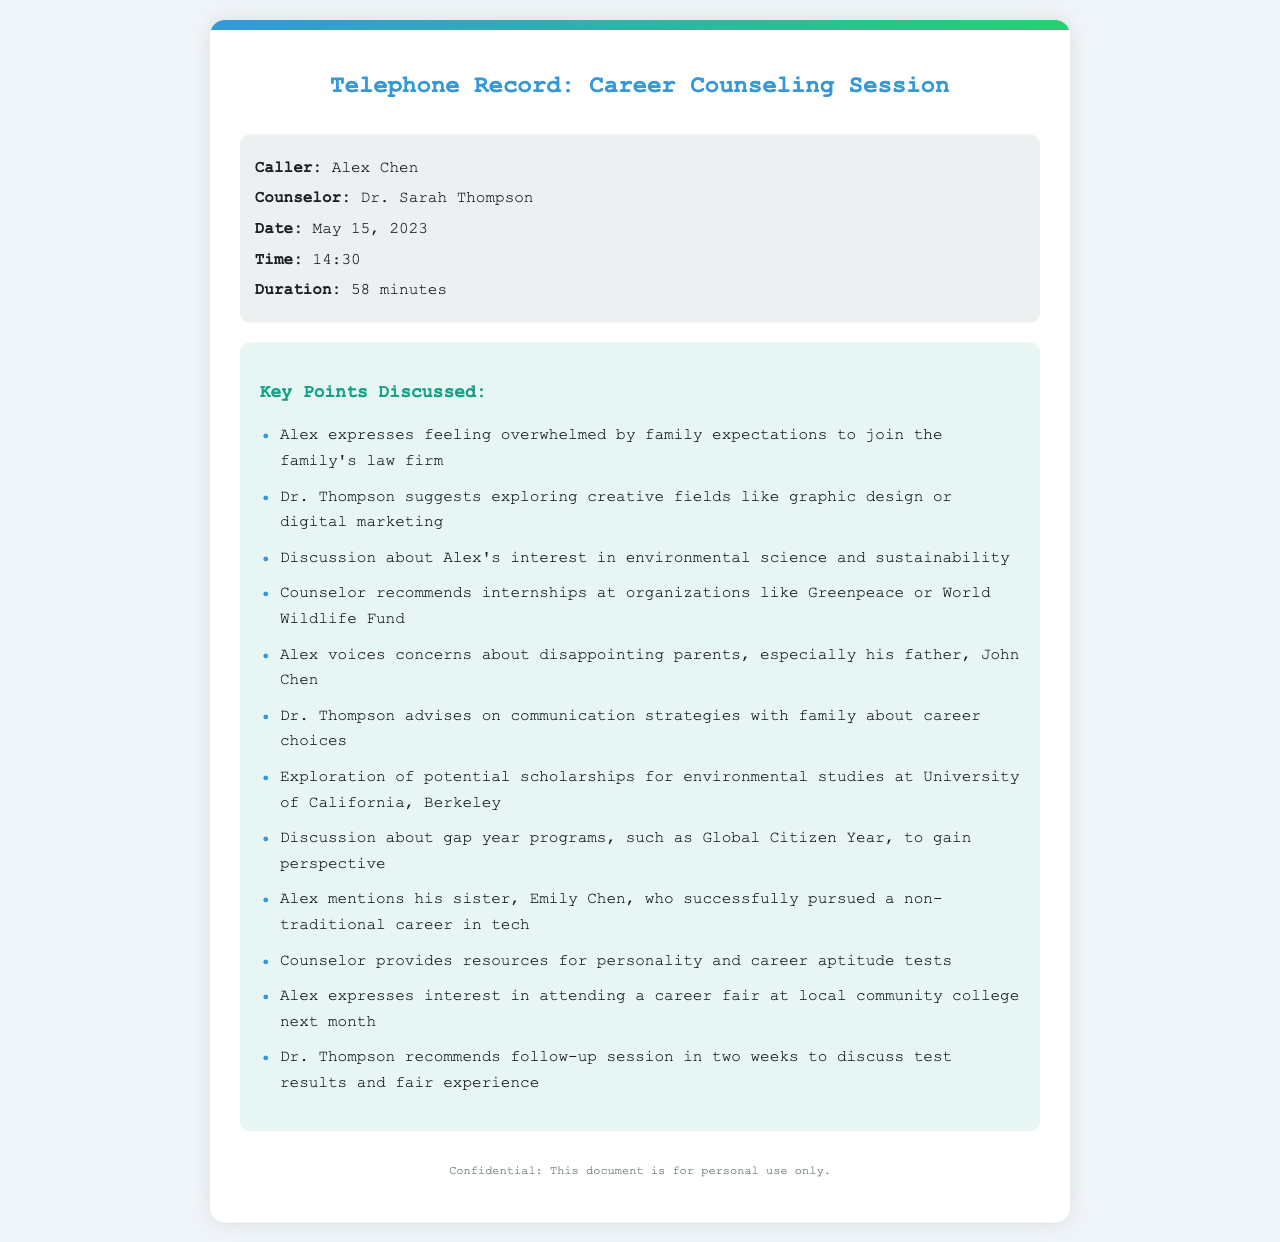What is the name of the caller? The caller's name, as specified in the document, is Alex Chen.
Answer: Alex Chen Who is the counselor? The counselor's name mentioned in the document is Dr. Sarah Thompson.
Answer: Dr. Sarah Thompson What was the date of the call? The date of the call is clearly stated in the document as May 15, 2023.
Answer: May 15, 2023 How long did the phone call last? The duration of the call is mentioned as 58 minutes.
Answer: 58 minutes What was one of the alternative career paths suggested? The counselor suggested exploring creative fields, specifically graphic design or digital marketing.
Answer: graphic design What concern did Alex express regarding his career choice? Alex voiced concerns about disappointing his parents, particularly his father, John Chen.
Answer: disappointing parents Which organization did Dr. Thompson recommend for internships? The counselor recommended internships at Greenpeace or the World Wildlife Fund.
Answer: Greenpeace or World Wildlife Fund What did Dr. Thompson advise about discussing career choices with family? Dr. Thompson advised on communication strategies with family regarding career choices.
Answer: communication strategies What scholarship opportunity was discussed? Potential scholarships for environmental studies at University of California, Berkeley were discussed.
Answer: University of California, Berkeley What is one event Alex is interested in attending? Alex expressed interest in attending a career fair at a local community college next month.
Answer: career fair at local community college 